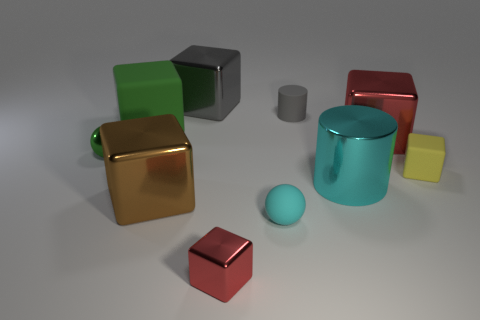Is the shape of the big shiny thing that is behind the large green rubber object the same as  the large green object?
Your answer should be very brief. Yes. How many balls have the same size as the cyan metallic cylinder?
Your response must be concise. 0. What number of red metallic blocks are behind the red metal thing in front of the large red object?
Offer a terse response. 1. Do the small green ball that is left of the gray metal cube and the brown object have the same material?
Offer a terse response. Yes. Do the red object on the left side of the metal cylinder and the large thing to the left of the big brown block have the same material?
Your answer should be very brief. No. Is the number of rubber cubes in front of the tiny yellow cube greater than the number of large green metallic cubes?
Make the answer very short. No. What color is the rubber block to the left of the matte block in front of the large matte object?
Keep it short and to the point. Green. What is the shape of the cyan shiny thing that is the same size as the gray metallic block?
Your answer should be very brief. Cylinder. There is a object that is the same color as the big shiny cylinder; what is its shape?
Your answer should be compact. Sphere. Are there the same number of yellow things that are behind the big gray block and large cylinders?
Offer a terse response. No. 